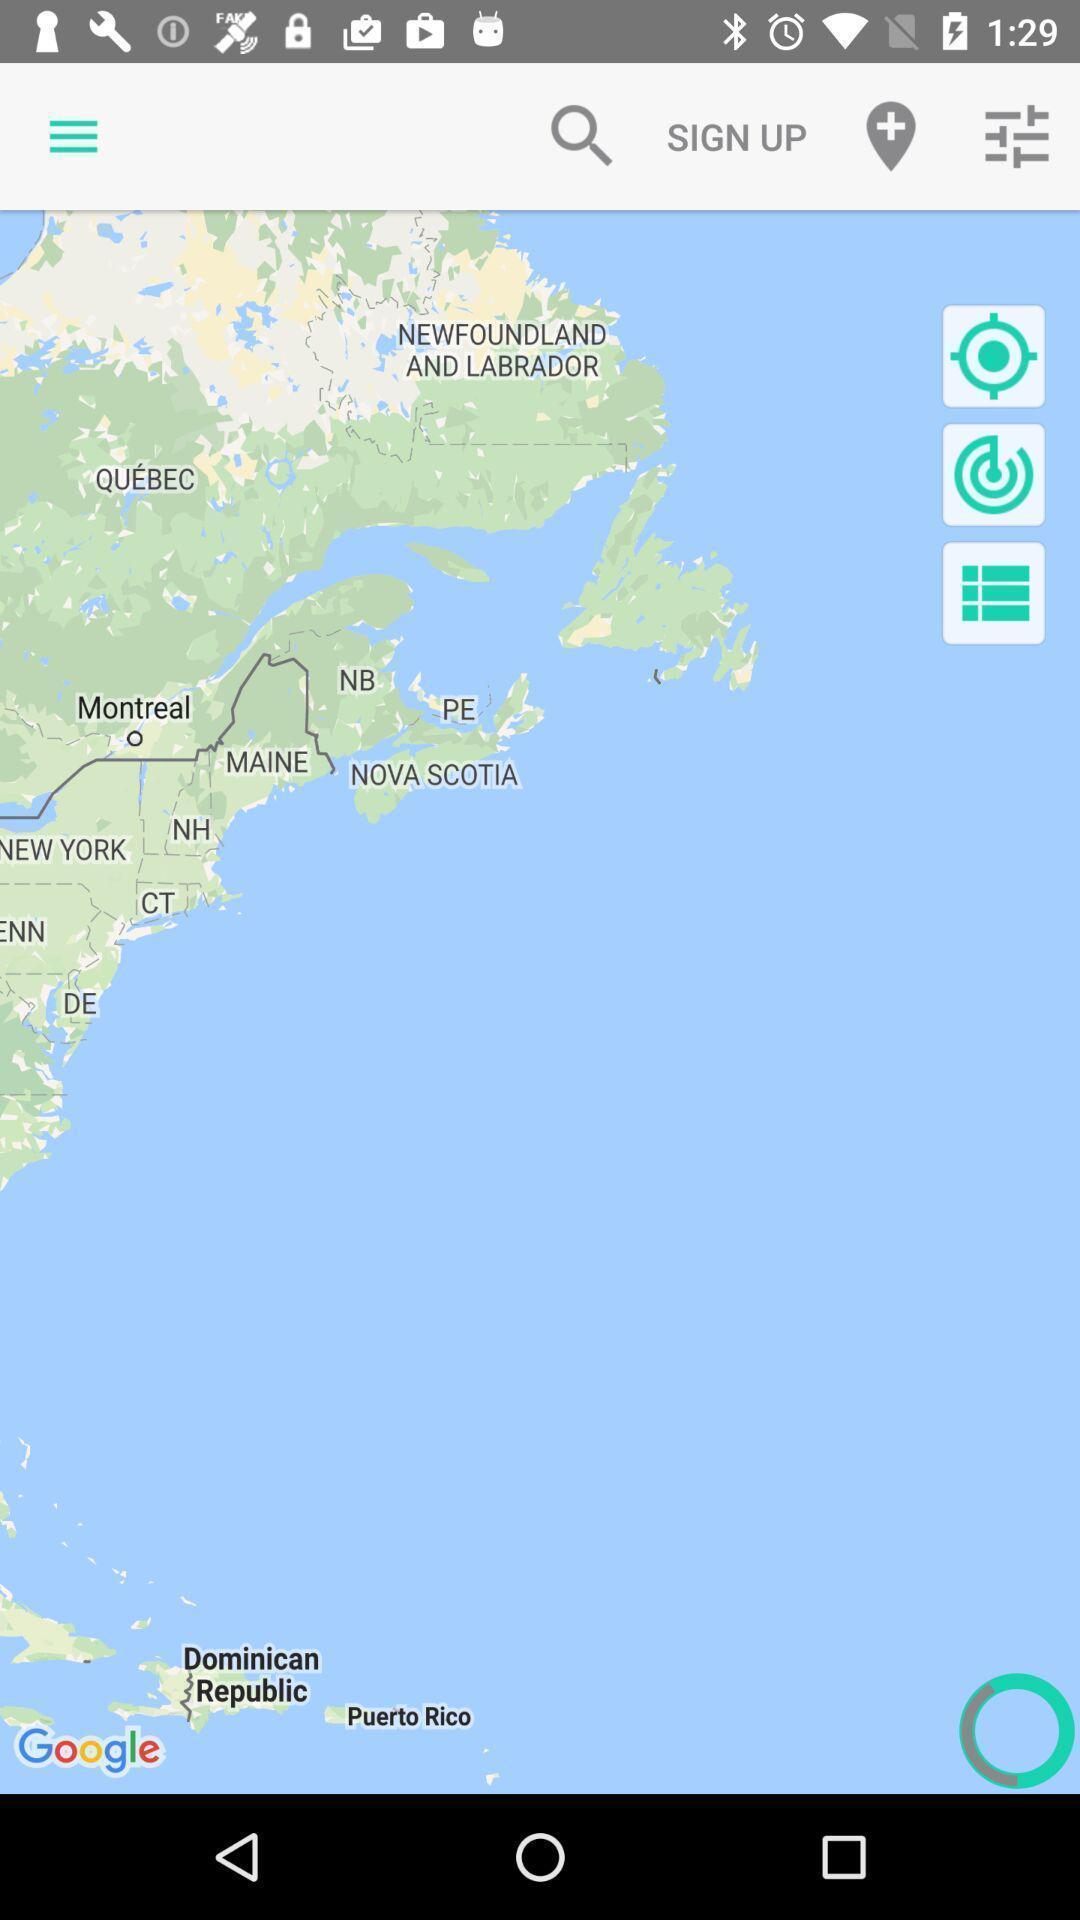Please provide a description for this image. Page displaying different countries in location app. 